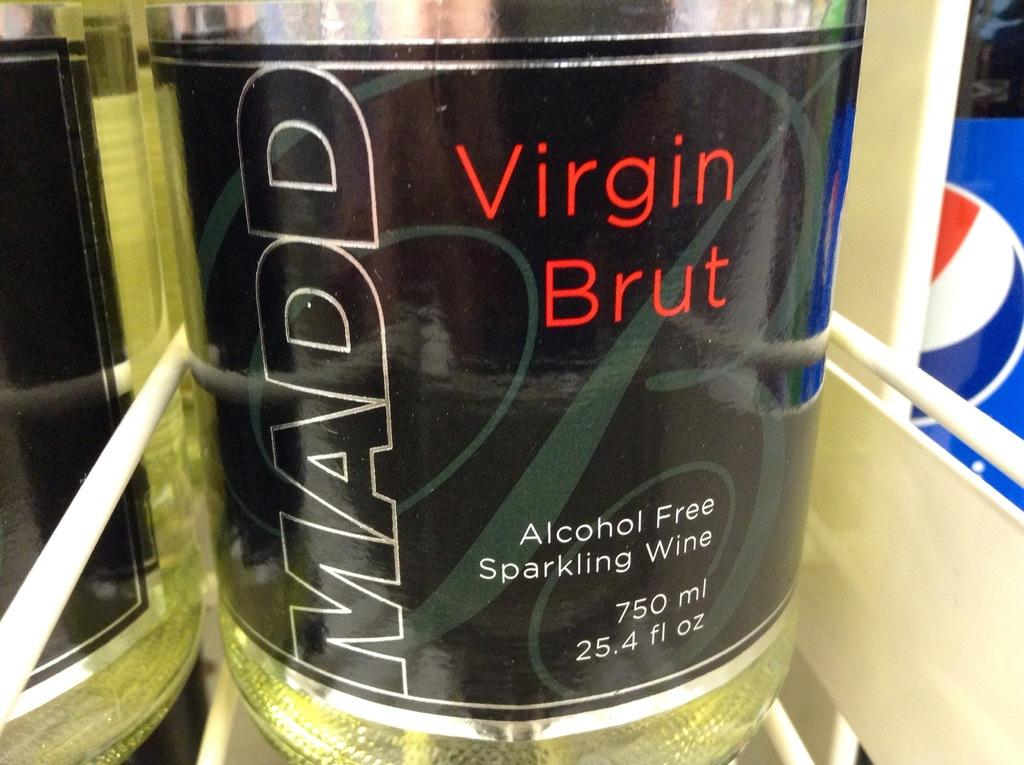What is located in the middle of the image? There is a bottle in the middle of the image. What type of quartz can be seen in the image? There is no quartz present in the image; it only features a bottle. Can you describe the crook in the image? There is no crook present in the image. 